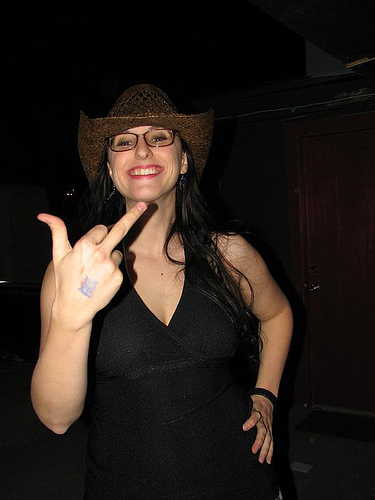<image>
Is the middle finger in front of the woman? Yes. The middle finger is positioned in front of the woman, appearing closer to the camera viewpoint. 